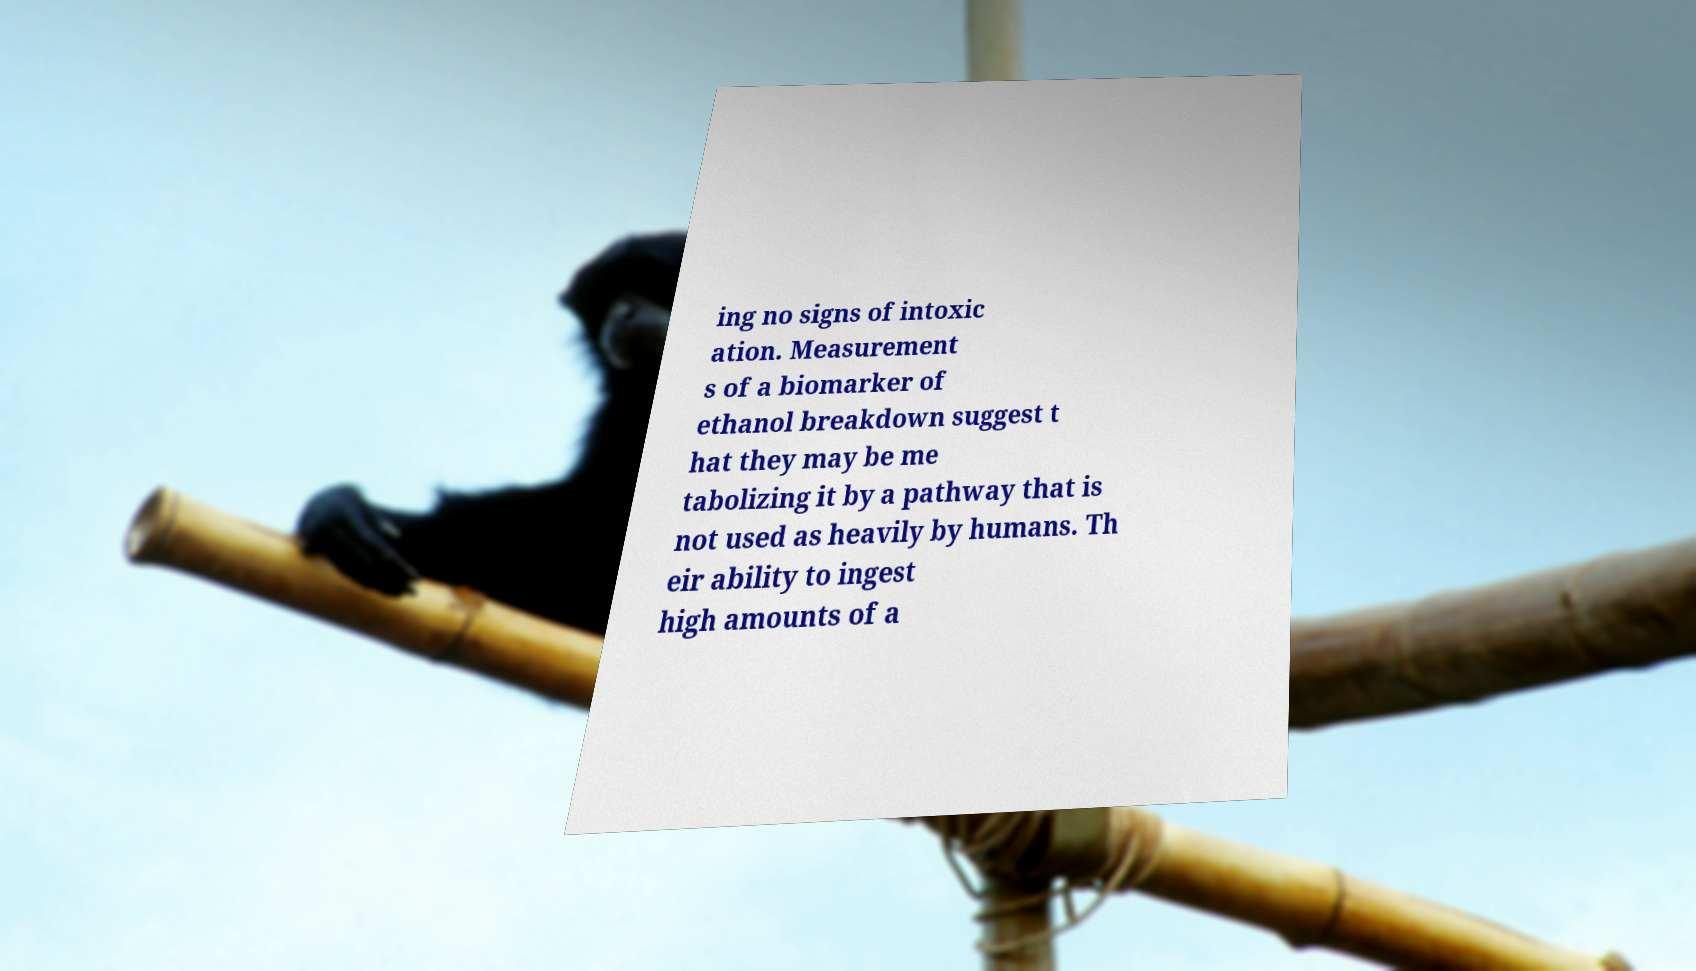Could you extract and type out the text from this image? ing no signs of intoxic ation. Measurement s of a biomarker of ethanol breakdown suggest t hat they may be me tabolizing it by a pathway that is not used as heavily by humans. Th eir ability to ingest high amounts of a 